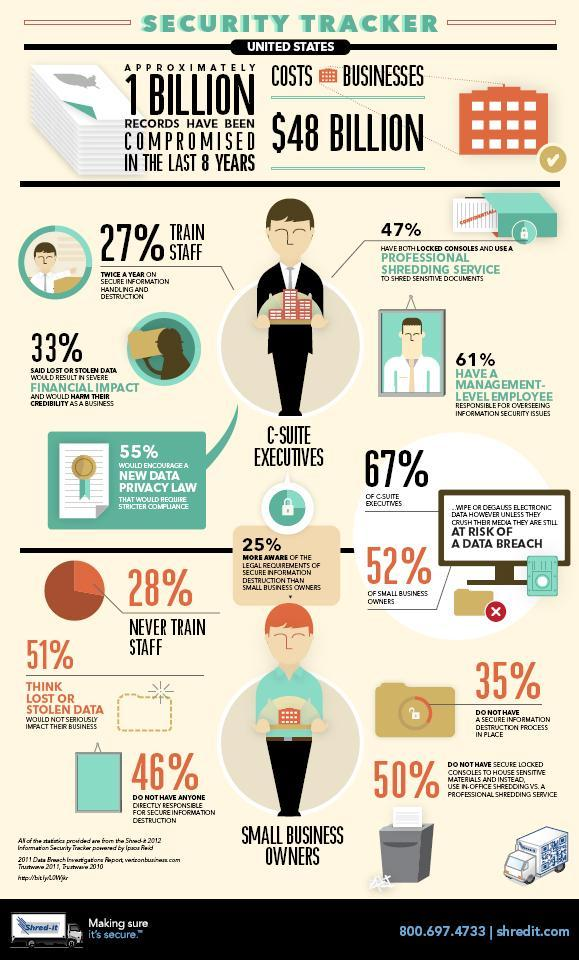What percentage of executives do not feel that stolen data can have a financial impact?
Answer the question with a short phrase. 67% What percentage of small business owners have locked console for storing sensitive materials? 50% What percentage of executives is not interested in a new data privacy law? 45% Who among the two, C-Suite executives or small business owners, are at more risk of data breach? C Suite Executives What is the percentage of small business owners think that data stolen has a big impact on their business? 49% What percentage of C-level executive do not have a management employee to oversee information security issues? 39% 